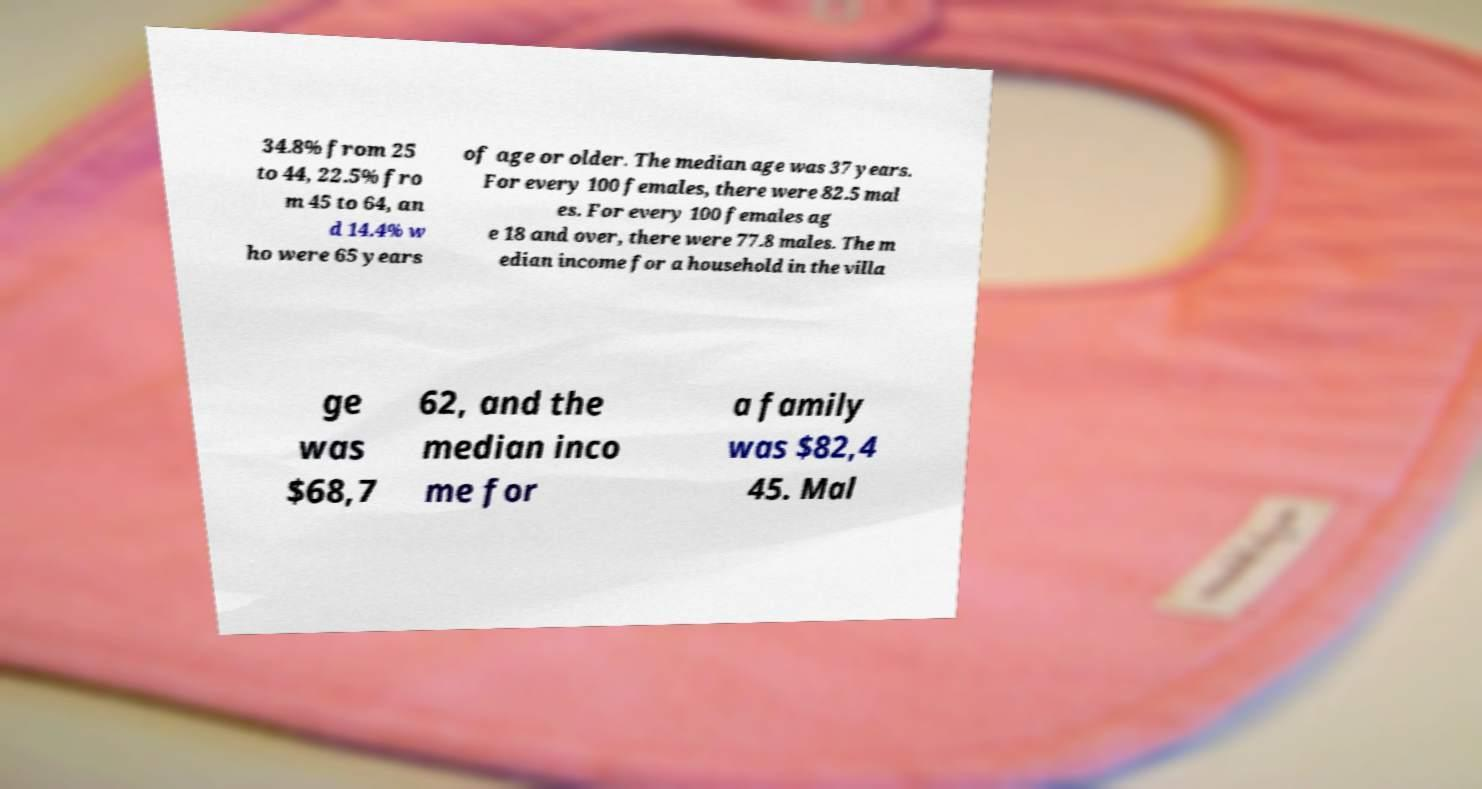I need the written content from this picture converted into text. Can you do that? 34.8% from 25 to 44, 22.5% fro m 45 to 64, an d 14.4% w ho were 65 years of age or older. The median age was 37 years. For every 100 females, there were 82.5 mal es. For every 100 females ag e 18 and over, there were 77.8 males. The m edian income for a household in the villa ge was $68,7 62, and the median inco me for a family was $82,4 45. Mal 